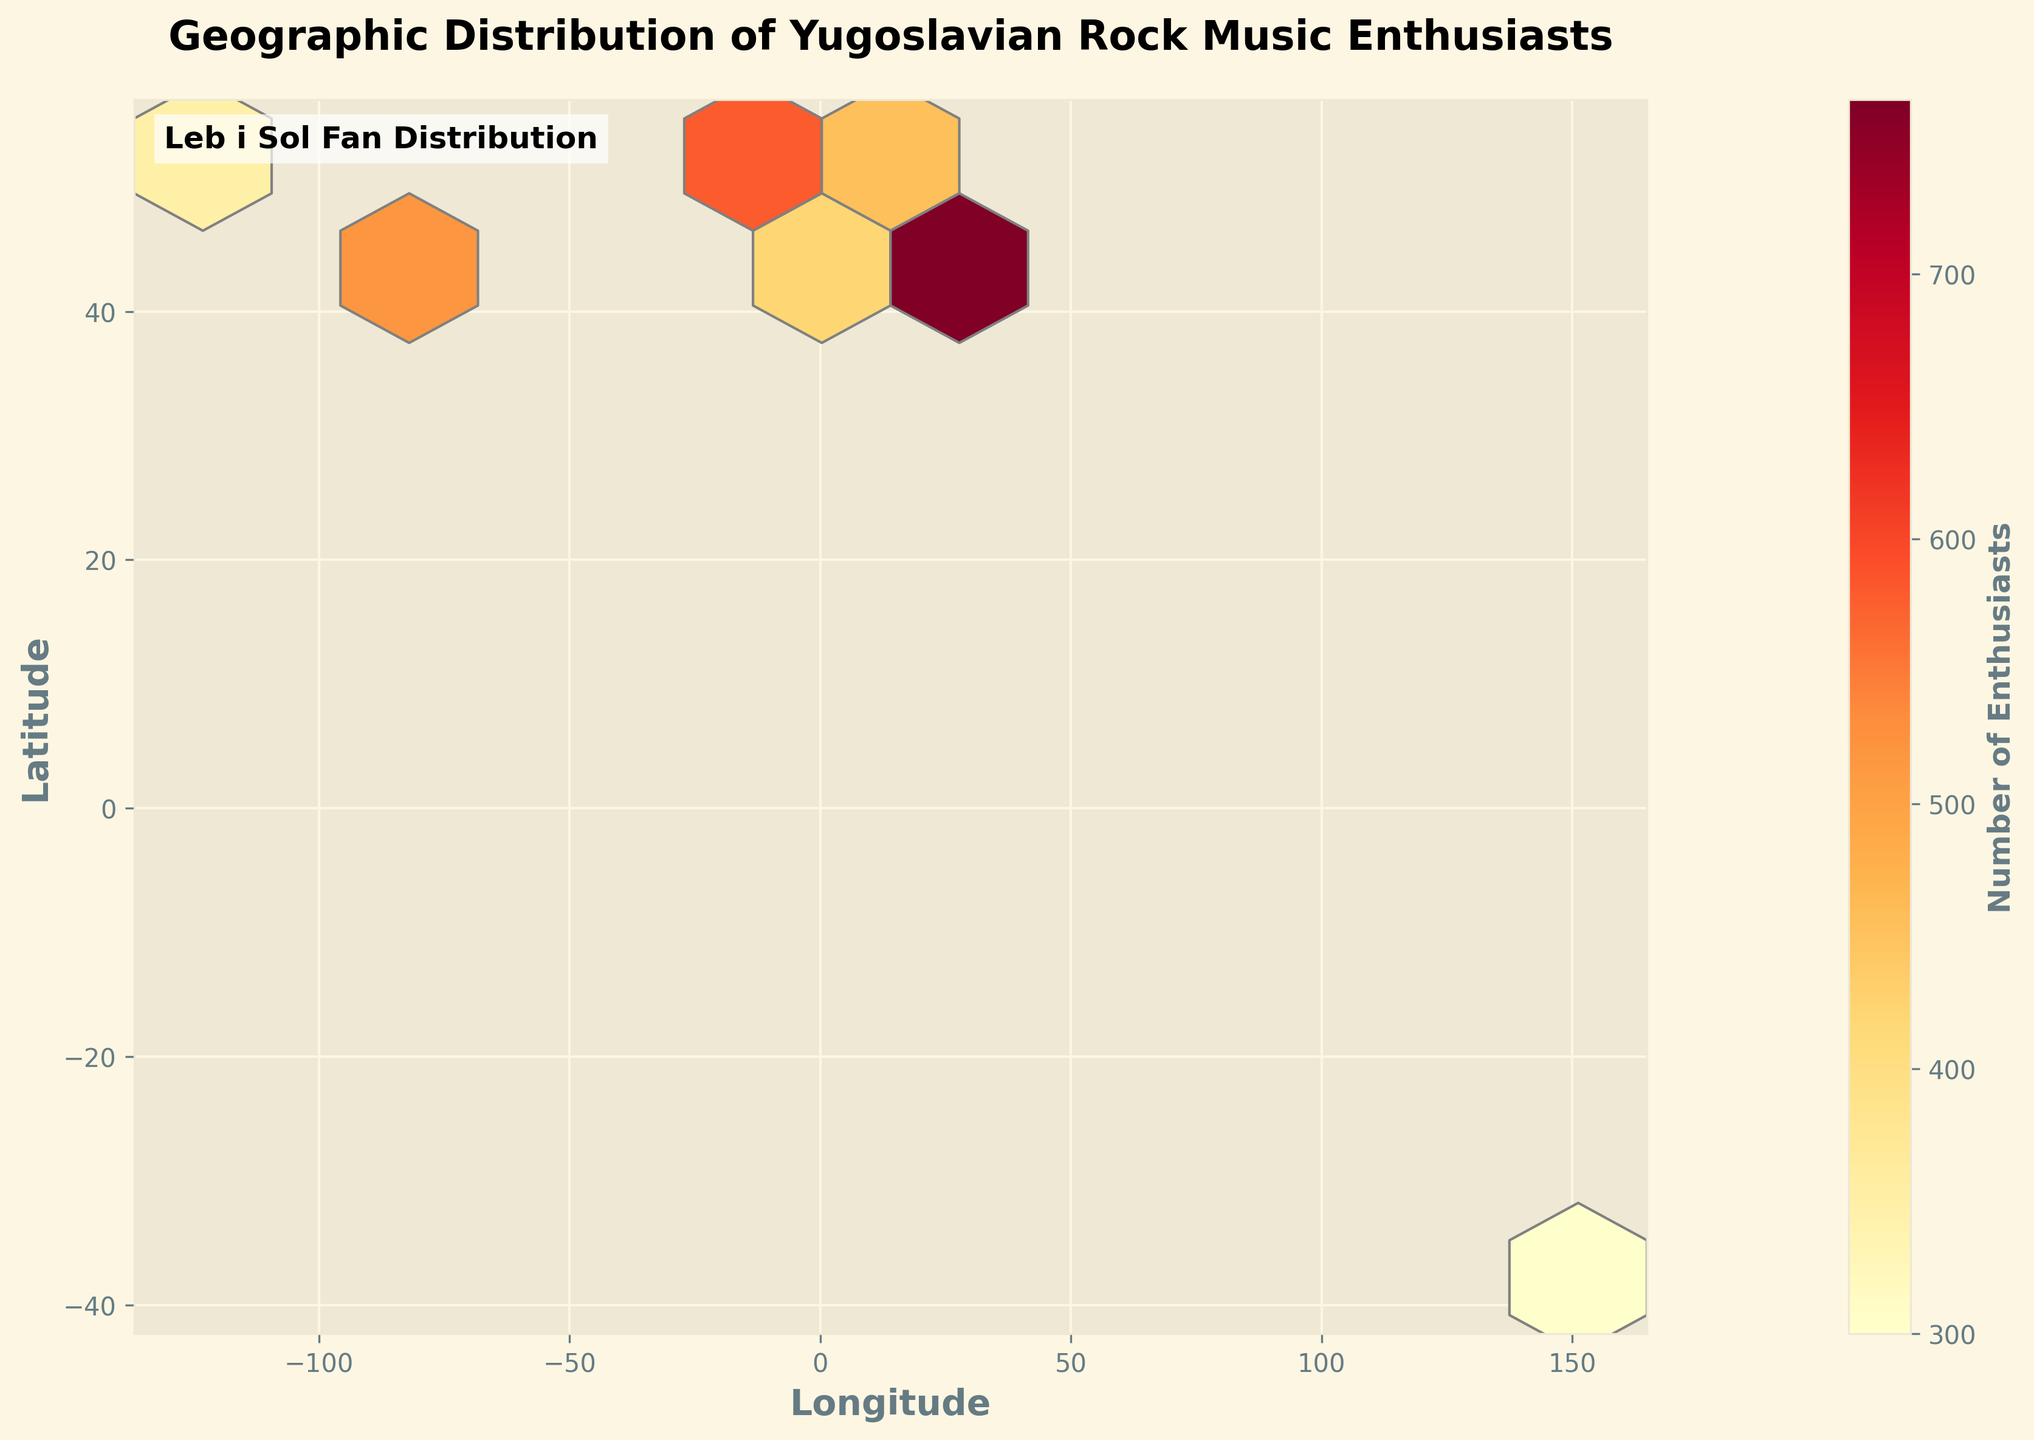What is the title of the figure? The title is found at the top of the plot and provides a description of what is being visualized. Here, it serves to indicate the purpose of the plot, which is to show the distribution of Yugoslavian rock music enthusiasts.
Answer: Geographic Distribution of Yugoslavian Rock Music Enthusiasts What continents show a significant presence of Yugoslavian rock music enthusiasts? By observing the geographic locations with darker hexagons, you can identify continents like Europe, North America, and Australia, which have notable concentrations.
Answer: Europe, North America, Australia Which city has the highest number of enthusiasts according to the plot? Identify the city with the darkest or largest hexagon and check the color bar to see which color corresponds to the highest number of enthusiasts.
Answer: Belgrade Describe the color gradient used in the color mapping of the plot. Look at the color bar and see how colors transition from one value to another; typically, this indicates the range of frequencies, from low to high values.
Answer: The gradient ranges from yellow (low values) to red (high values) What is the average number of enthusiasts in the top three cities? Sum up the number of enthusiasts for the top three cities. Divide the total by three to find the average. The top three cities by enthusiasts are Belgrade (1200), Zagreb (980), and Skopje (850). (1200 + 980 + 850) / 3 = 3430 / 3 = 1143.33
Answer: 1143.33 How does the distribution of enthusiasts in North America compare to Europe? Observe the number and density of hexagons in each continent. Europe appears to have more clusters and darker hexagons compared to North America, which indicates a higher concentration.
Answer: Europe has a higher concentration Which city has the least number of enthusiasts in the plot? Find the location with the lightest hexagon according to the color scale. In the dataset, Amsterdam has the least number of enthusiasts.
Answer: Amsterdam How many cities have over 700 enthusiasts? Check the color bar to see the range that corresponds to 700 enthusiasts and identify cities within that range. Cities are Belgrade (1200), Zagreb (980), Skopje (850), Sarajevo (720), and New York (750).
Answer: Five cities What is the latitude range covered in the plot? Observe the y-axis which represents the latitude; the lowest and highest values on the axis will give the range.
Answer: From roughly -38 to 52 degrees Explain why there might be a concentration of enthusiasts in certain cities. Consider historical, cultural, and demographic factors. Cities with larger diaspora communities from the former Yugoslavia are likely to have higher numbers of enthusiasts.
Answer: Larger diaspora populations in those cities 